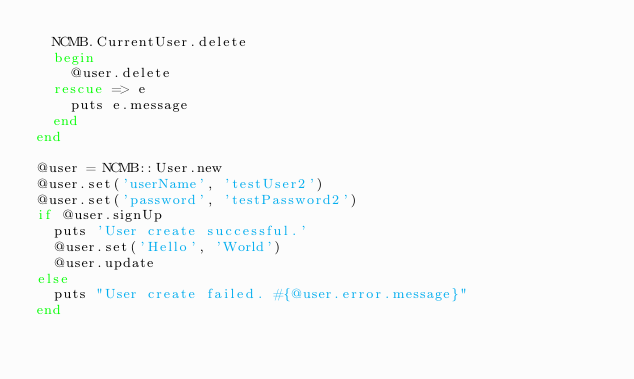<code> <loc_0><loc_0><loc_500><loc_500><_Ruby_>  NCMB.CurrentUser.delete
  begin
    @user.delete
  rescue => e
    puts e.message
  end
end

@user = NCMB::User.new
@user.set('userName', 'testUser2')
@user.set('password', 'testPassword2')
if @user.signUp
  puts 'User create successful.'
  @user.set('Hello', 'World')
  @user.update
else
  puts "User create failed. #{@user.error.message}"
end
</code> 